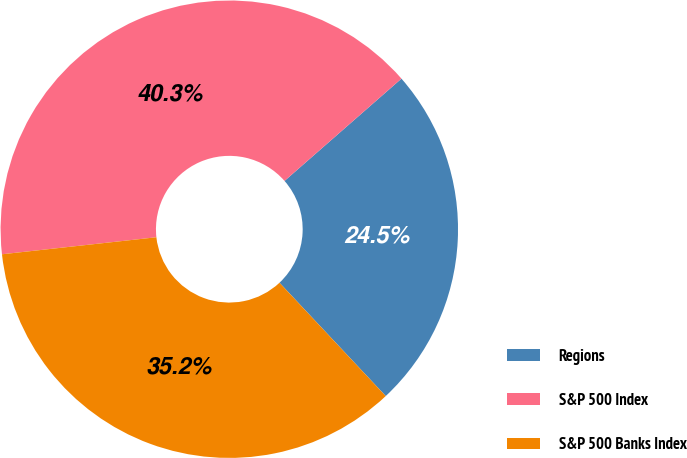<chart> <loc_0><loc_0><loc_500><loc_500><pie_chart><fcel>Regions<fcel>S&P 500 Index<fcel>S&P 500 Banks Index<nl><fcel>24.45%<fcel>40.31%<fcel>35.24%<nl></chart> 